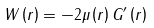<formula> <loc_0><loc_0><loc_500><loc_500>W \left ( r \right ) = - 2 \mu \left ( r \right ) G ^ { \prime } \left ( r \right )</formula> 